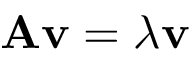Convert formula to latex. <formula><loc_0><loc_0><loc_500><loc_500>A v = \lambda v</formula> 